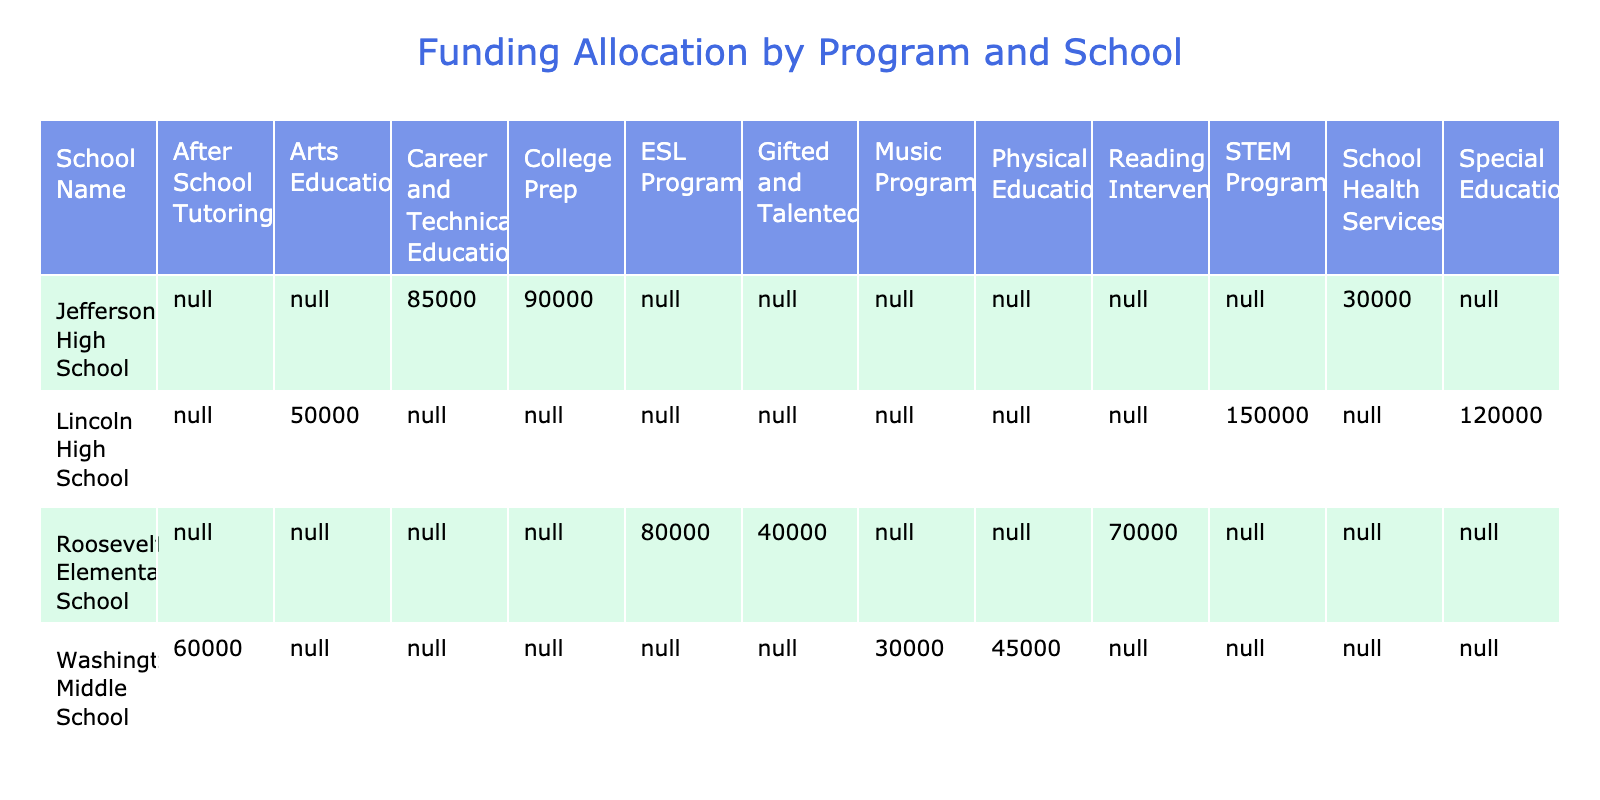What is the total funding allocated to Lincoln High School? The funding allocations for Lincoln High School are STEM Programs ($150,000), Arts Education ($50,000), and Special Education ($120,000). Adding these values together gives: 150,000 + 50,000 + 120,000 = 320,000.
Answer: 320000 Which school received the highest funding allocation for a single program? The program with the highest funding allocation is the STEM Programs at Lincoln High School, which received $150,000. No other program in the table exceeds this amount.
Answer: Lincoln High School (STEM Programs, $150,000) Is the total funding for after-school tutoring higher than the total funding for music programs? After School Tutoring at Washington Middle School received $60,000 and the Music Program at the same school received $30,000. Since $60,000 is greater than $30,000, the statement is true.
Answer: Yes What is the average funding allocation for Roosevelt Elementary School's programs? The funding allocations for Roosevelt Elementary School are Reading Intervention ($70,000), ESL Program ($80,000), and Gifted and Talented ($40,000). The sum is 70,000 + 80,000 + 40,000 = 190,000. Then, dividing by the number of programs (3) gives an average of 190,000 / 3 = 63,333.33.
Answer: 63333.33 Which school has the lowest total funding allocation? The total funding allocation for Washington Middle School is $60,000 (After School Tutoring) + $45,000 (Physical Education) + $30,000 (Music Program) = $135,000. Jefferson High School totals $300,000 and Lincoln High School totals $320,000. Therefore, Washington Middle School has the lowest total funding allocation.
Answer: Washington Middle School What percentage of Lincoln High School's funding is allocated to Special Education? The total funding allocated to Lincoln High School is $320,000. The funding for Special Education is $120,000. To find the percentage, (120,000 / 320,000) * 100 = 37.5%.
Answer: 37.5% Is there a program in Jefferson High School that exceeds the funding of any programs at Roosevelt Elementary School? Jefferson High School has College Prep ($90,000) and Career and Technical Education ($85,000), both of which exceed the highest allocation at Roosevelt Elementary School, which is $80,000 for the ESL Program. So, this statement is true.
Answer: Yes What is the difference in funding between the highest and lowest programs at Washington Middle School? The highest funding at Washington Middle School is for After School Tutoring at $60,000, and the lowest is for the Music Program at $30,000. The difference is calculated as 60,000 - 30,000 = 30,000.
Answer: 30000 What is the total funding across all schools? The total funding allocations are as follows: Lincoln High School ($320,000) + Washington Middle School ($135,000) + Roosevelt Elementary School ($220,000) + Jefferson High School ($300,000). Adding these, we get: 320,000 + 135,000 + 220,000 + 300,000 = 1,075,000.
Answer: 1075000 